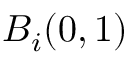Convert formula to latex. <formula><loc_0><loc_0><loc_500><loc_500>B _ { i } ( 0 , 1 )</formula> 